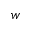Convert formula to latex. <formula><loc_0><loc_0><loc_500><loc_500>w</formula> 